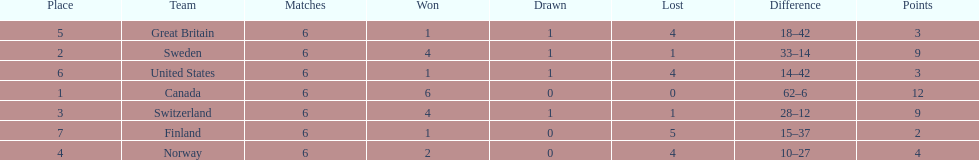What was the number of points won by great britain? 3. 